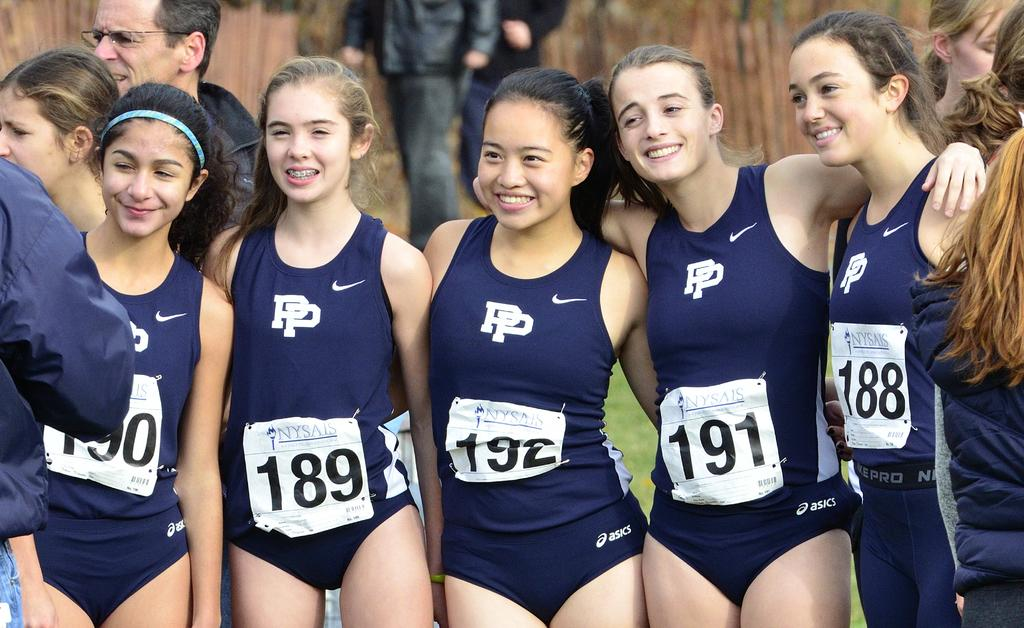<image>
Summarize the visual content of the image. Swimmer 191 has her arms around swimmers 192 and 188. 